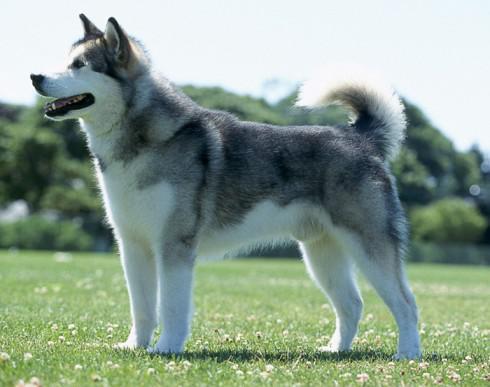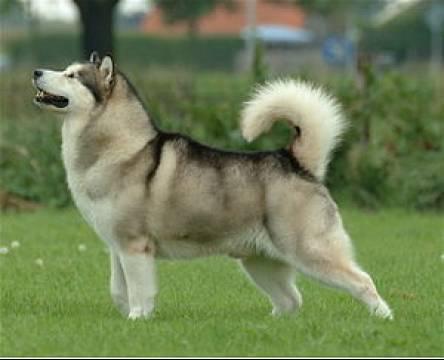The first image is the image on the left, the second image is the image on the right. Examine the images to the left and right. Is the description "All dogs are standing with bodies in profile, at least one with its tail curled inward toward its back, and the dogs in the left and right images gaze in the same direction." accurate? Answer yes or no. Yes. The first image is the image on the left, the second image is the image on the right. For the images shown, is this caption "The right image contains one dog standing on green grass." true? Answer yes or no. Yes. 